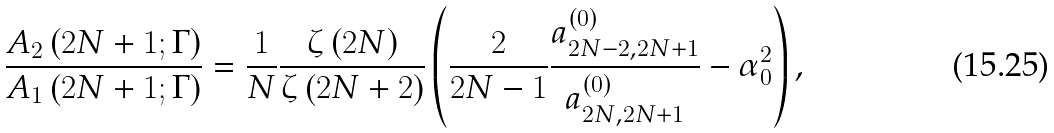<formula> <loc_0><loc_0><loc_500><loc_500>\frac { A _ { 2 } \left ( 2 N + 1 ; \Gamma \right ) } { A _ { 1 } \left ( 2 N + 1 ; \Gamma \right ) } = \frac { 1 } { N } \frac { \zeta \left ( 2 N \right ) } { \zeta \left ( 2 N + 2 \right ) } \left ( \frac { 2 } { 2 N - 1 } \frac { a _ { 2 N - 2 , 2 N + 1 } ^ { \left ( 0 \right ) } } { a _ { 2 N , 2 N + 1 } ^ { \left ( 0 \right ) } } - \alpha _ { 0 } ^ { 2 } \right ) ,</formula> 